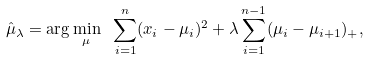Convert formula to latex. <formula><loc_0><loc_0><loc_500><loc_500>\hat { \mu } _ { \lambda } = \arg \min _ { \mu } \ \sum _ { i = 1 } ^ { n } ( x _ { i } - \mu _ { i } ) ^ { 2 } + \lambda \sum _ { i = 1 } ^ { n - 1 } ( \mu _ { i } - \mu _ { i + 1 } ) _ { + } ,</formula> 